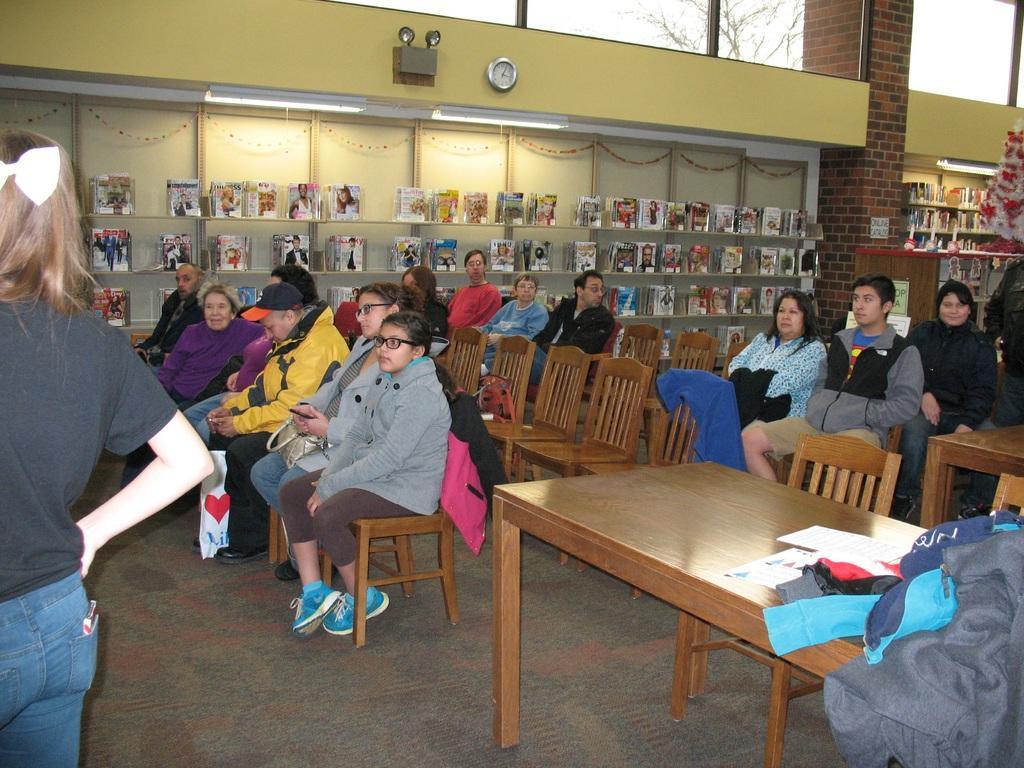How would you summarize this image in a sentence or two? This is a picture taken in a room, there are a group of people sitting on chairs and there is a table on the table there are paper and clothes. In front of the people there is a woman in black t shirt was standing on the floor. Behind the people there are shelves with full of books and wall on the wall there is a clock and lights. 